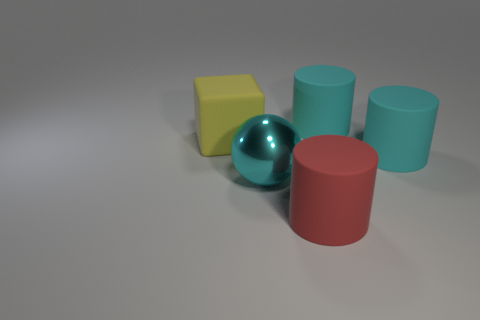Subtract all brown cylinders. Subtract all brown spheres. How many cylinders are left? 3 Add 2 big matte cubes. How many objects exist? 7 Subtract all balls. How many objects are left? 4 Subtract 0 gray balls. How many objects are left? 5 Subtract all large red cubes. Subtract all large metallic spheres. How many objects are left? 4 Add 1 yellow matte cubes. How many yellow matte cubes are left? 2 Add 3 blue metallic things. How many blue metallic things exist? 3 